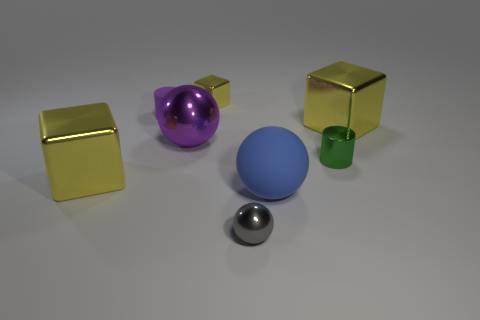Subtract all yellow cubes. How many were subtracted if there are1yellow cubes left? 2 Add 2 tiny green objects. How many objects exist? 10 Subtract all cylinders. How many objects are left? 6 Add 1 shiny things. How many shiny things are left? 7 Add 2 metal cylinders. How many metal cylinders exist? 3 Subtract 0 brown spheres. How many objects are left? 8 Subtract all small cylinders. Subtract all tiny purple rubber cylinders. How many objects are left? 5 